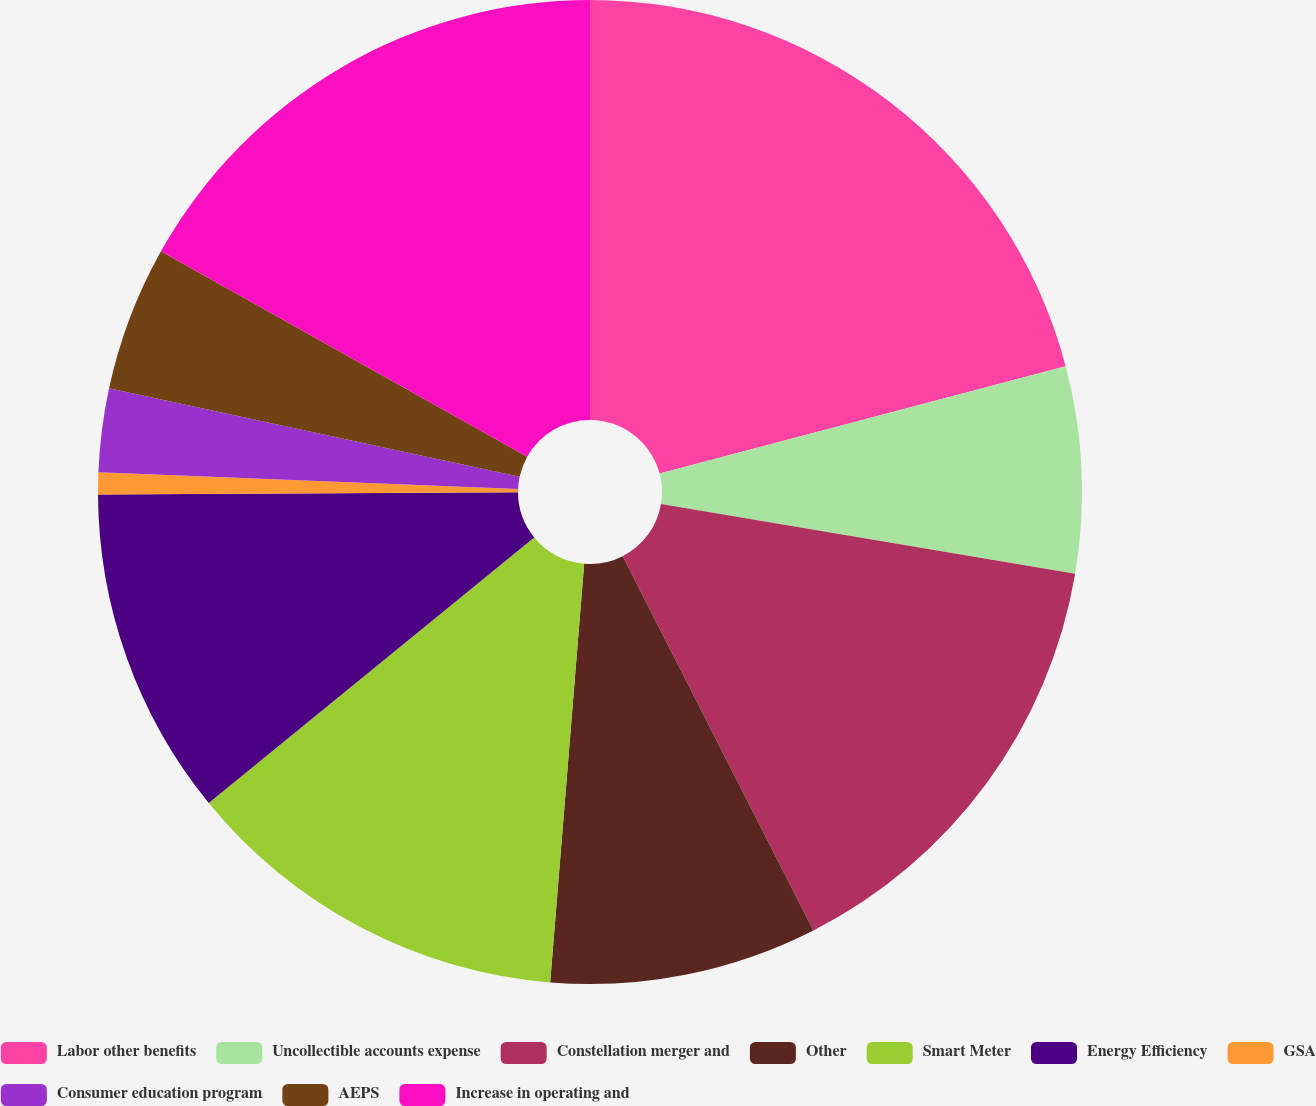Convert chart. <chart><loc_0><loc_0><loc_500><loc_500><pie_chart><fcel>Labor other benefits<fcel>Uncollectible accounts expense<fcel>Constellation merger and<fcel>Other<fcel>Smart Meter<fcel>Energy Efficiency<fcel>GSA<fcel>Consumer education program<fcel>AEPS<fcel>Increase in operating and<nl><fcel>20.89%<fcel>6.77%<fcel>14.84%<fcel>8.79%<fcel>12.82%<fcel>10.81%<fcel>0.72%<fcel>2.74%<fcel>4.76%<fcel>16.86%<nl></chart> 